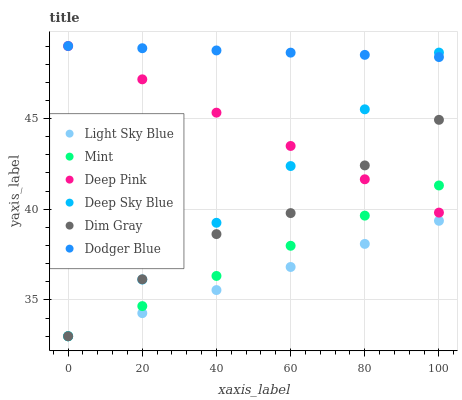Does Light Sky Blue have the minimum area under the curve?
Answer yes or no. Yes. Does Dodger Blue have the maximum area under the curve?
Answer yes or no. Yes. Does Deep Pink have the minimum area under the curve?
Answer yes or no. No. Does Deep Pink have the maximum area under the curve?
Answer yes or no. No. Is Deep Pink the smoothest?
Answer yes or no. Yes. Is Dim Gray the roughest?
Answer yes or no. Yes. Is Dodger Blue the smoothest?
Answer yes or no. No. Is Dodger Blue the roughest?
Answer yes or no. No. Does Dim Gray have the lowest value?
Answer yes or no. Yes. Does Deep Pink have the lowest value?
Answer yes or no. No. Does Dodger Blue have the highest value?
Answer yes or no. Yes. Does Light Sky Blue have the highest value?
Answer yes or no. No. Is Mint less than Dodger Blue?
Answer yes or no. Yes. Is Dodger Blue greater than Dim Gray?
Answer yes or no. Yes. Does Deep Pink intersect Dodger Blue?
Answer yes or no. Yes. Is Deep Pink less than Dodger Blue?
Answer yes or no. No. Is Deep Pink greater than Dodger Blue?
Answer yes or no. No. Does Mint intersect Dodger Blue?
Answer yes or no. No. 